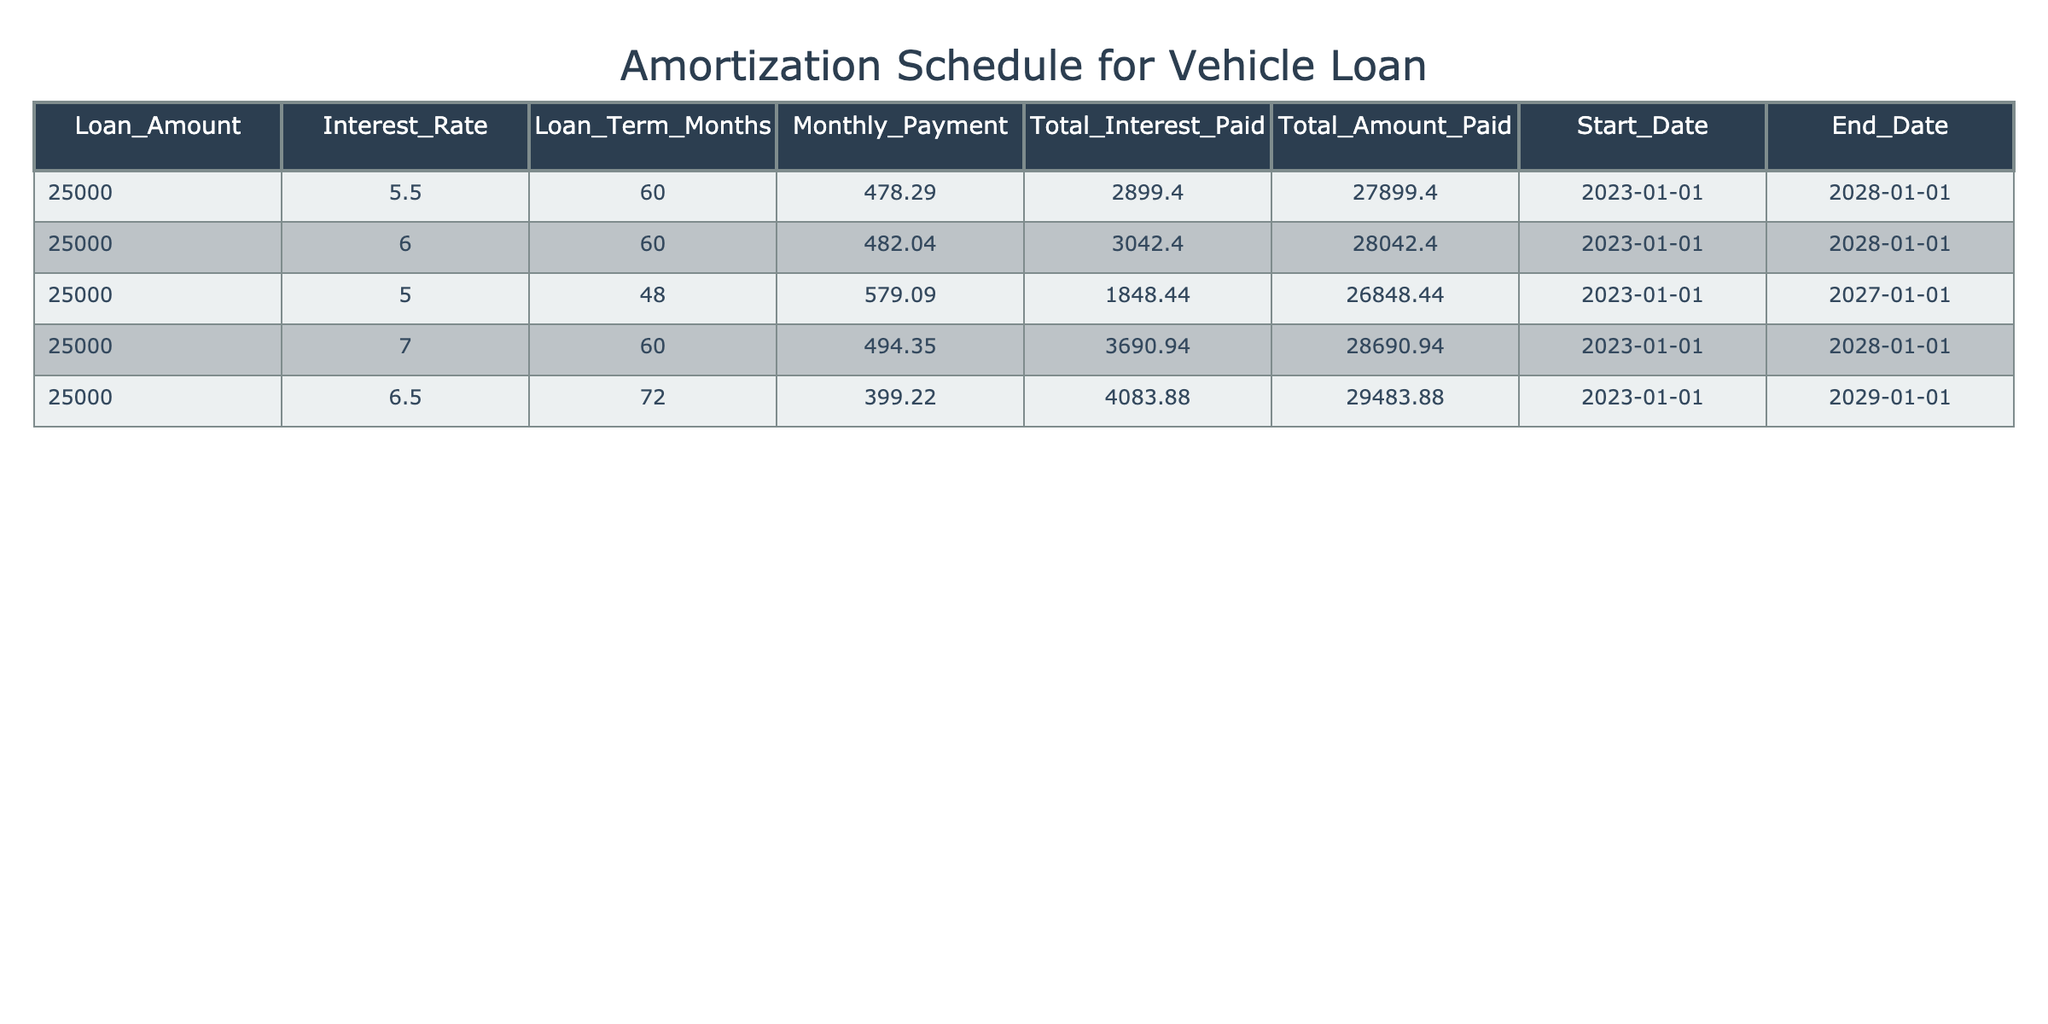What is the highest total interest paid among the loans? The total interest paid for each loan is listed in the table. Comparing the values, 3690.94 (7.0% interest) is the highest against others: 2899.40, 3042.40, 1848.44, and 4083.88. Thus, the maximum is 4083.88.
Answer: 4083.88 What is the monthly payment for the loan with a 5.5% interest rate? Referring to the loan with a 5.5% interest rate in the table, the monthly payment is explicitly provided as 478.29.
Answer: 478.29 Is there a loan term that has a total amount paid of less than 27,000? The total amounts paid for the loans listed are evaluated: 27899.40, 28042.40, 26848.44, 28690.94, and 29483.88. The only value under 27,000 is 26848.44. Therefore, the answer is yes, there is such a case.
Answer: Yes What is the average monthly payment across all loans? The monthly payments are 478.29, 482.04, 579.09, 494.35, and 399.22. Adding these yields 2413.99, and dividing by the number of loans (5) gives 482.80 as the average monthly payment.
Answer: 482.80 Which loan has the longest term and what is its total interest paid? Among the loan terms listed, 72 months is the longest, with a total interest paid of 4083.88 associated with the 6.5% interest rate loan.
Answer: 4083.88 What is the total amount paid for the loan with the highest interest rate? The loan with the highest interest rate (7.0%) has a total amount paid of 28690.94. This is directly stated in the table.
Answer: 28690.94 Are all loans taken out starting on the same date? All the loans in the table have a start date of 2023-01-01 as indicated in the data. Thus, the answer is yes.
Answer: Yes What is the difference in total amount paid between the loans at 5.0% and 7.0% interest rates? The total amount paid for the 5.0% loan is 26848.44 and for the 7.0% loan is 28690.94. The difference is calculated as 28690.94 - 26848.44, resulting in 842.50.
Answer: 842.50 